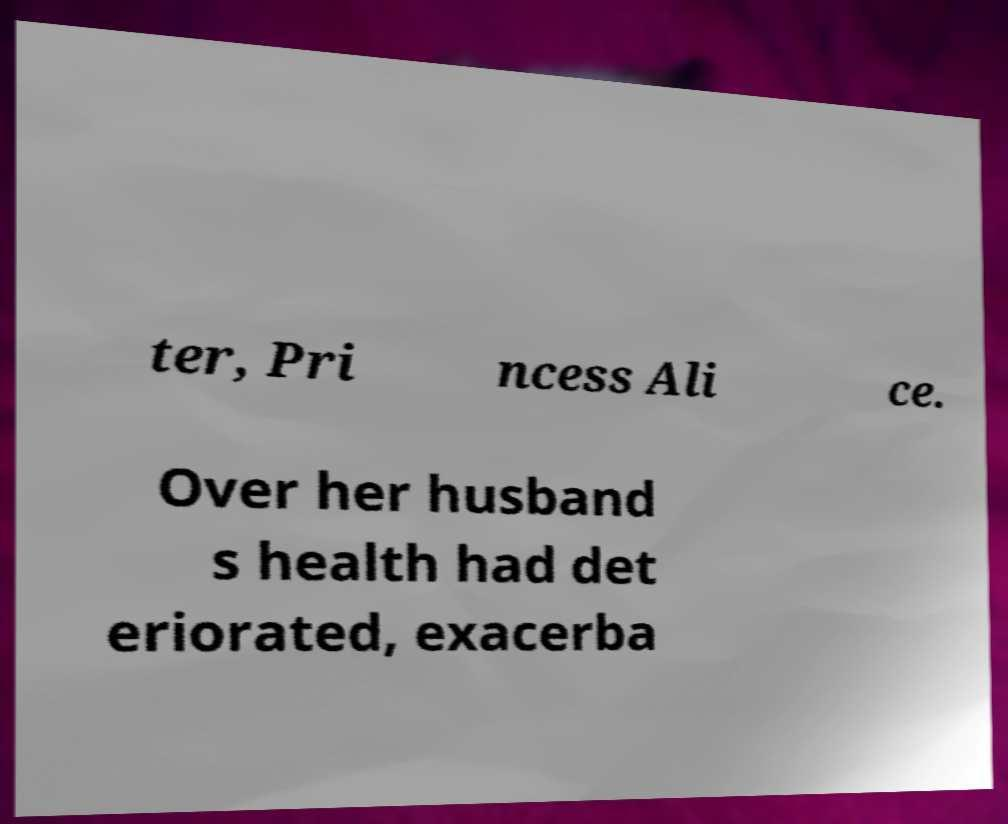Can you accurately transcribe the text from the provided image for me? ter, Pri ncess Ali ce. Over her husband s health had det eriorated, exacerba 